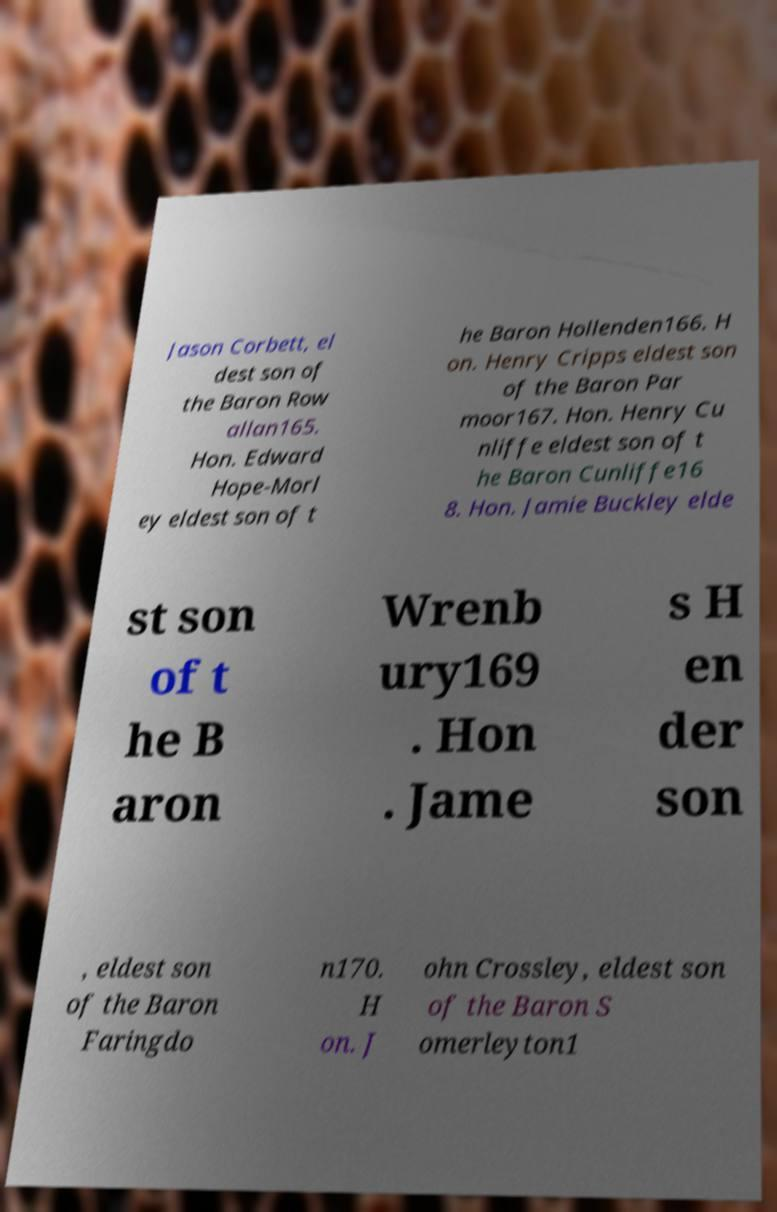Can you read and provide the text displayed in the image?This photo seems to have some interesting text. Can you extract and type it out for me? Jason Corbett, el dest son of the Baron Row allan165. Hon. Edward Hope-Morl ey eldest son of t he Baron Hollenden166. H on. Henry Cripps eldest son of the Baron Par moor167. Hon. Henry Cu nliffe eldest son of t he Baron Cunliffe16 8. Hon. Jamie Buckley elde st son of t he B aron Wrenb ury169 . Hon . Jame s H en der son , eldest son of the Baron Faringdo n170. H on. J ohn Crossley, eldest son of the Baron S omerleyton1 